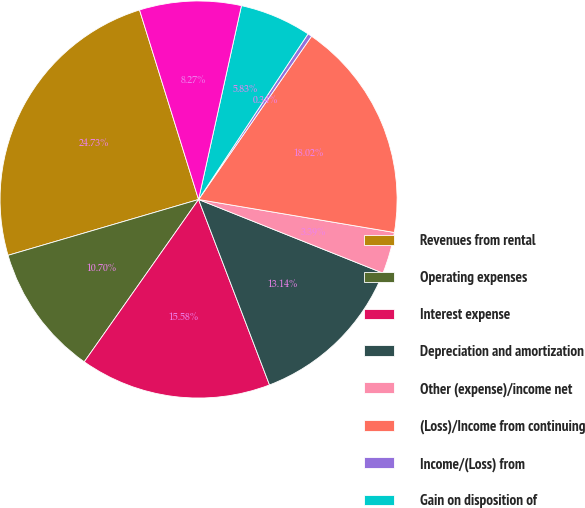Convert chart to OTSL. <chart><loc_0><loc_0><loc_500><loc_500><pie_chart><fcel>Revenues from rental<fcel>Operating expenses<fcel>Interest expense<fcel>Depreciation and amortization<fcel>Other (expense)/income net<fcel>(Loss)/Income from continuing<fcel>Income/(Loss) from<fcel>Gain on disposition of<fcel>Net (loss)/income<nl><fcel>24.73%<fcel>10.7%<fcel>15.58%<fcel>13.14%<fcel>3.39%<fcel>18.02%<fcel>0.34%<fcel>5.83%<fcel>8.27%<nl></chart> 